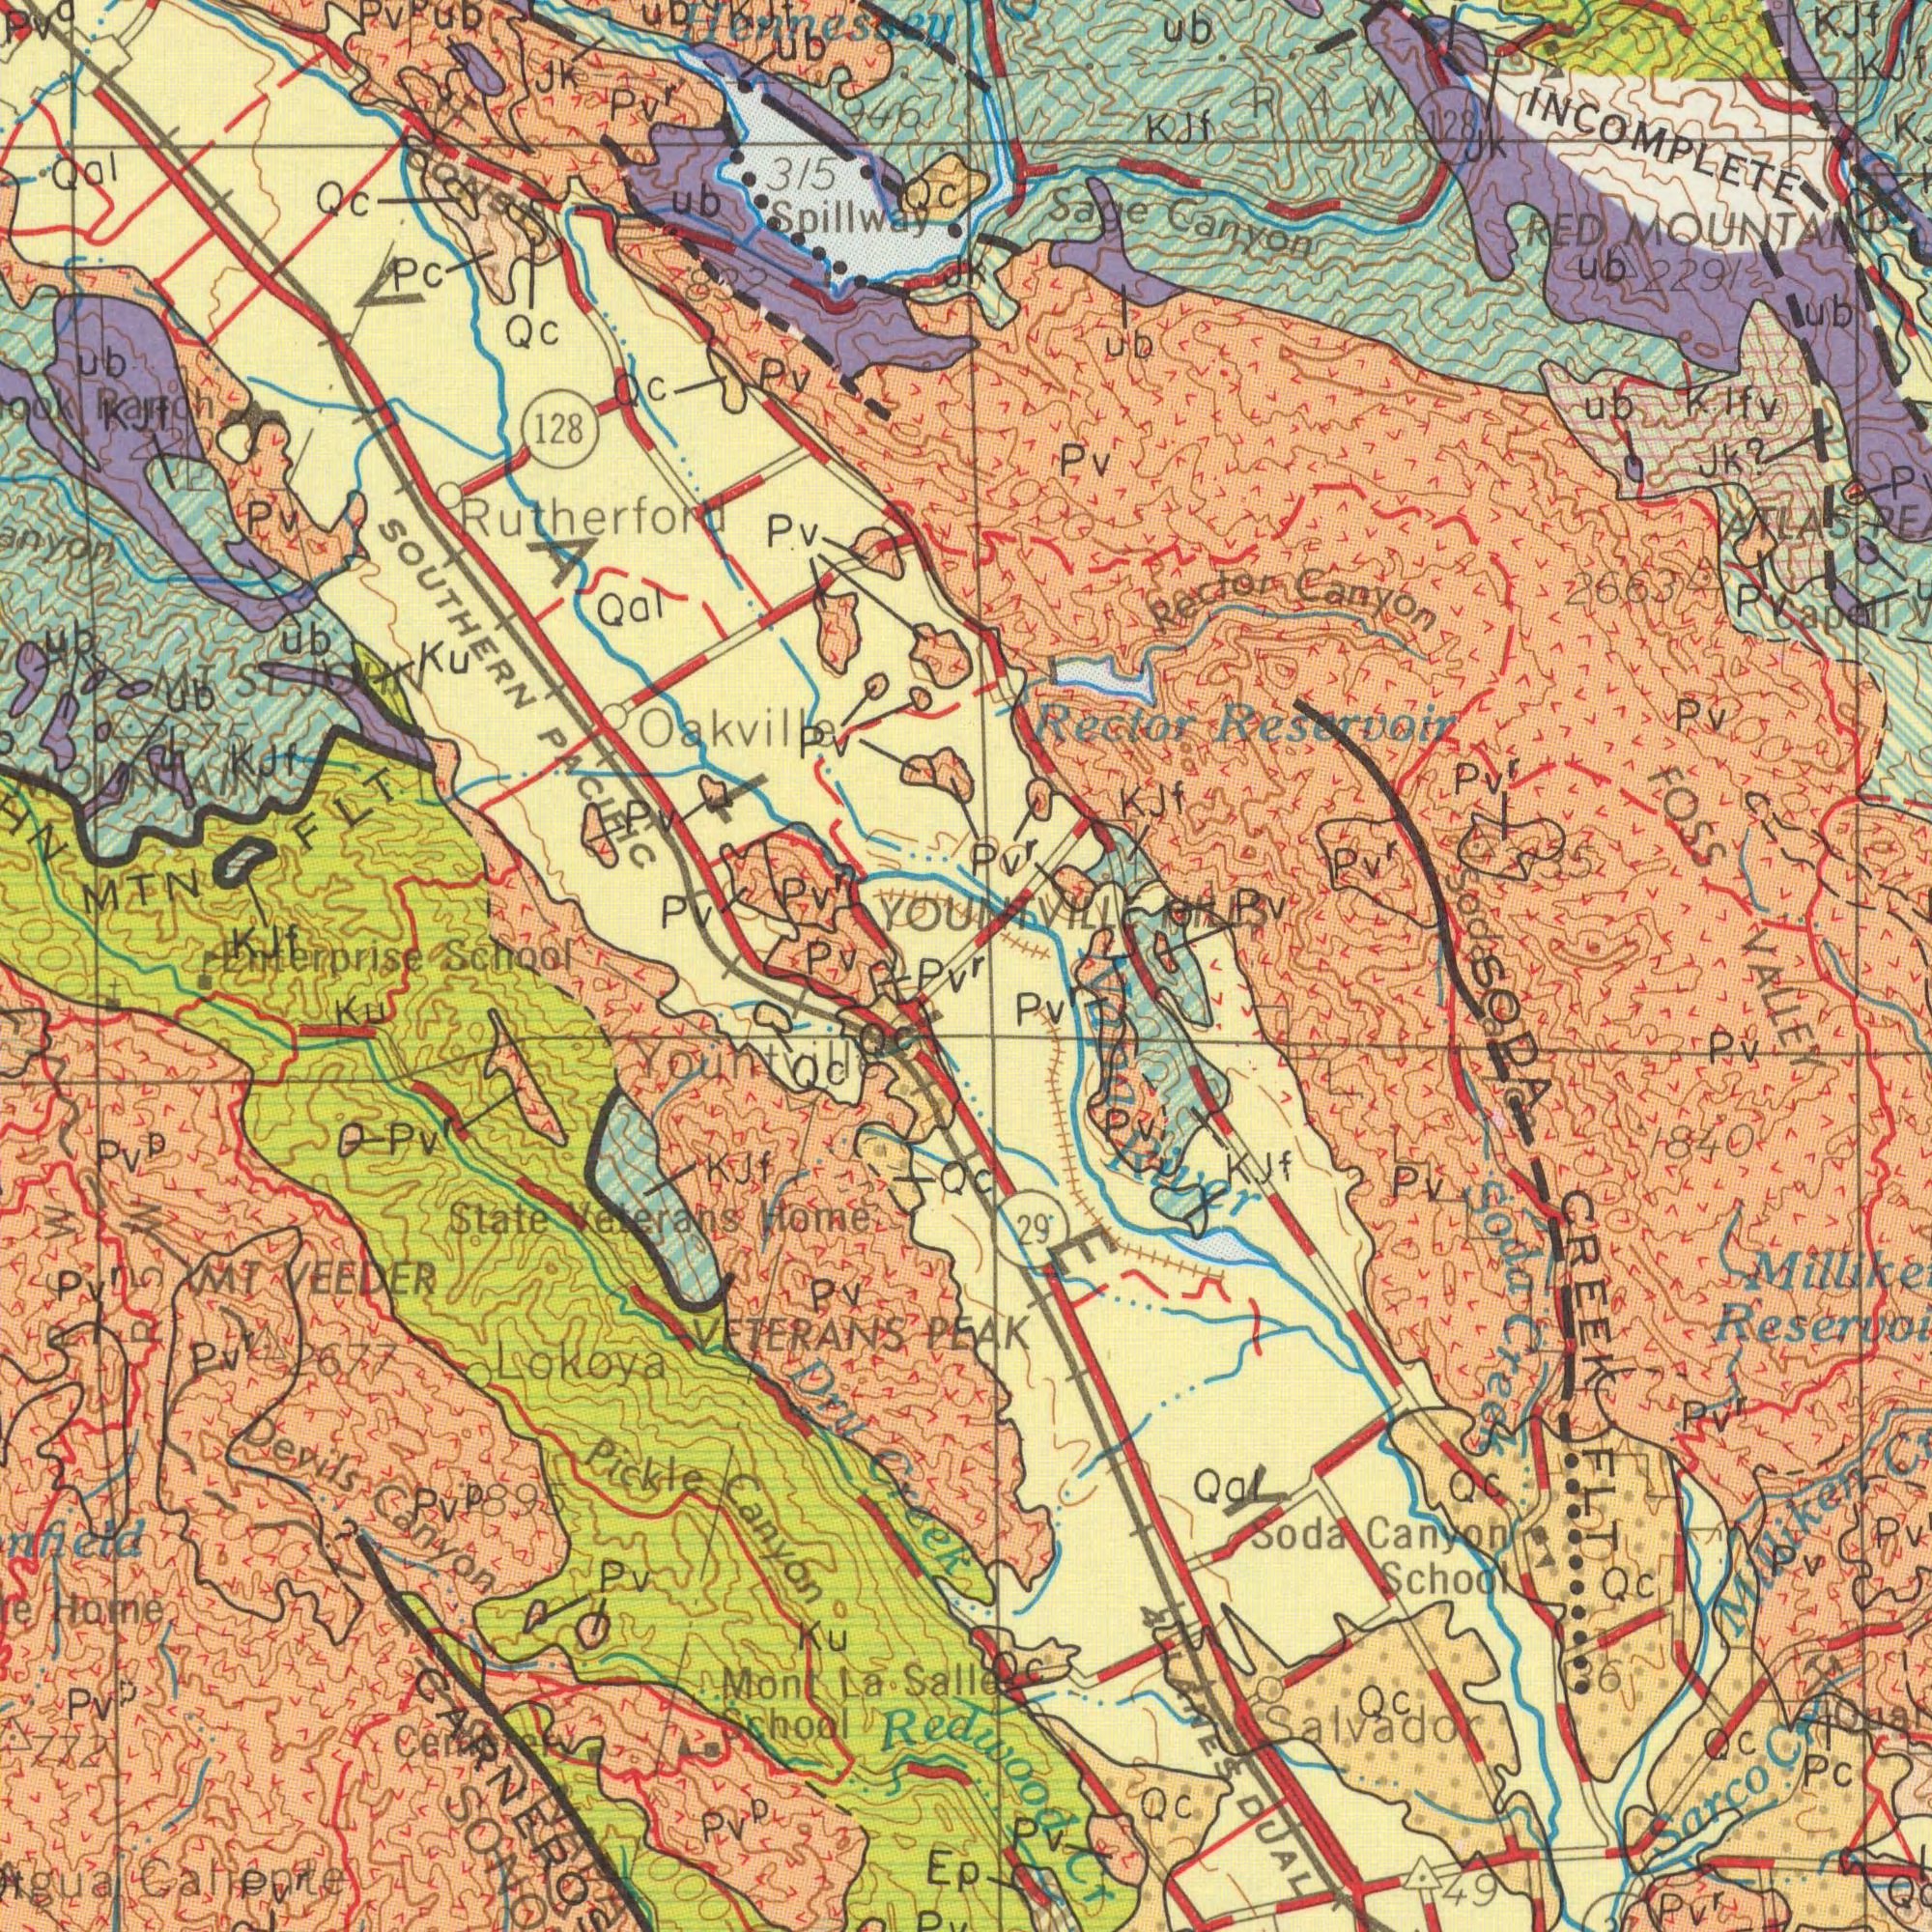What text can you see in the top-right section? YOUNTVILLE HILLS Rector Reservoir Sage Canyon RED MOUNTAN Kjf Jk? Rector Canyon ub ub KJf ub R 4 W Pv<sup>r</sup> 128 INCOMPLETE Capell FOSS ub Pv Pv 2291 Pv<sup>r</sup> Pv<sup>r</sup> ATLAS 2663 Kjf lfv k. Pv Pv ub KJf 2135 Soda 100 What text can you see in the bottom-right section? VALLEY PEAK Soda Canyon School Sarco Cr Milliken Pc 29° 4 LANES DUAL Pv<sup>r</sup> Qc SODA CREEK FLT QC Qc Qc Redwood Cr Pv<sup>r</sup> Pv<sup>r</sup> Soda Creek Napa Rivr Pv Pv Pv<sup>r</sup> Quar 49 Salvador Qc Pv KJF Qal 36 Pv ###on 1840 Qc Pv What text is shown in the top-left quadrant? SOUTHERN PACIFIC 128 315 MTN FLT Pc Spillway ub Jk Qc Pv Qal ub Rutherford ub Pv Pv<sup>p</sup> Qc Ranch Pv<sup>r</sup> Oakvile Qc Pv CONST Qal Ub Pv<sup>a</sup> Ku Pv<sup>r</sup> Qc KJf ub kjt Hennessey Pv Pv Pv MOUNTAIN KJF 2375 ub MT ST JOHN KJF 946 VALLEY ub Eanterprise School 832 Pv 220 What text can you see in the bottom-left section? Lokoya Pickle Canyon State Veterans Home MT VEEDER Devils Canyon Home Mont La Salle Scholl Caliente Dry Creek Pv<sup>p</sup> KJf Ku Ku VETERANS Qc Pv<sup>r</sup> Pv Ep 772 Pv Qc Yountville 2677 Pv<sup>p</sup> Qc Pv<sup>r</sup> Pv<sup>p</sup> Pv<sup>p</sup> 895 Pv<sup>r</sup> Pv<sup>r</sup> Pv<sup>r</sup> P C W R 5 W 1000 Cemetery 